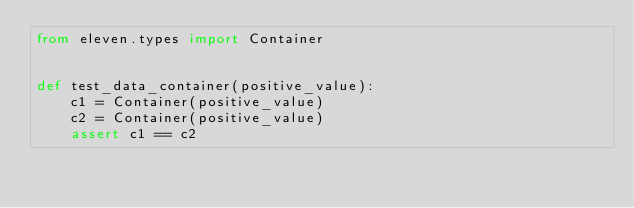<code> <loc_0><loc_0><loc_500><loc_500><_Python_>from eleven.types import Container


def test_data_container(positive_value):
    c1 = Container(positive_value)
    c2 = Container(positive_value)
    assert c1 == c2
</code> 